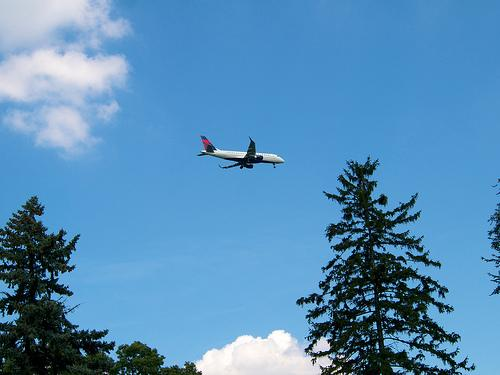Describe the condition of the sky between the clouds. The sky in between the clouds is light blue with a clear and serene appearance. What type of trees can be seen in the image and how would you describe their appearance? There are tall sparse green pine trees that have a slightly bent and thin appearance. How many engines are on the passenger plane? The passenger plane has two visible engines. Name a color that appears prominently in the sky of the image. Light blue. Please provide a description of the plane's tail colors. The tail of the plane has a combination of red and blue colors. How many wings can be seen on the plane, and where are they located? Two wings are visible on the plane, one on the left side and one on the right side. What is behind the airplane in the sky? A large landscape filled with tall green pine trees, sporadic wispy clouds, and clear light blue sky. In the image, describe the cloud located at the bottom center. It's a billowing white cloud situated near the middle at the bottom portion of the image. Can the landing wheels of the airplane be seen? If so, describe their appearance. Yes, the protruding landing wheels on the plane are visible and they appear to be in the process of retracting. What is the primary object in the image and what activity is it involved in? A white airplane with blue and red on its tail is flying through the sky over trees. How many clouds can be visibly identified in the image? Three clouds What is the background color of this image between the clouds? A light blue sky Identify the object at the coordinates X:198 Y:130 with a width of 15 and a height of 15. The tail fin of the airplane What is the color of the airplane's tail fin? Blue and red Is it a cloudy, clear, or partly cloudy day in the image? Partly cloudy Which part of the airplane is painted red and blue? The tail fin Is the quality of the image high or low? High What type of plane is captured in the image? Passenger plane Identify the main object that is flying in the sky. A white airplane Describe the most prominent natural feature in the image. A tall sparse pine tree What type of trees can be seen underneath the airplane? Pine trees Is there any abnormality detected in the image? No What does the text on the airplane say? There is no text. Can you see any landing gear on the airplane in the image? Yes, protruding landing wheels Describe one visible attribute of the airplane's wings. One rudder on each wing In this image, is the airplane closer to the top or the bottom of the picture? The top Which side of the airplane is visible in the image? Right side Describe the interaction between the airplane and the trees. The airplane is flying above the trees. Identify the main emotion evoked by this image. Calm Name one color on the nose of the airplane. White 